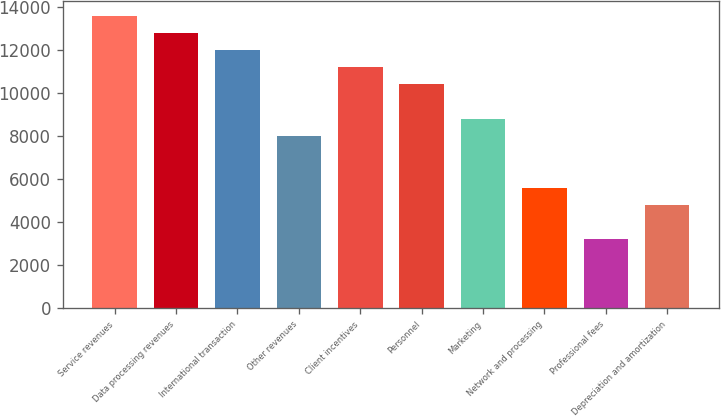Convert chart to OTSL. <chart><loc_0><loc_0><loc_500><loc_500><bar_chart><fcel>Service revenues<fcel>Data processing revenues<fcel>International transaction<fcel>Other revenues<fcel>Client incentives<fcel>Personnel<fcel>Marketing<fcel>Network and processing<fcel>Professional fees<fcel>Depreciation and amortization<nl><fcel>13619<fcel>12818<fcel>12017<fcel>8012<fcel>11216<fcel>10415<fcel>8813<fcel>5609<fcel>3206<fcel>4808<nl></chart> 